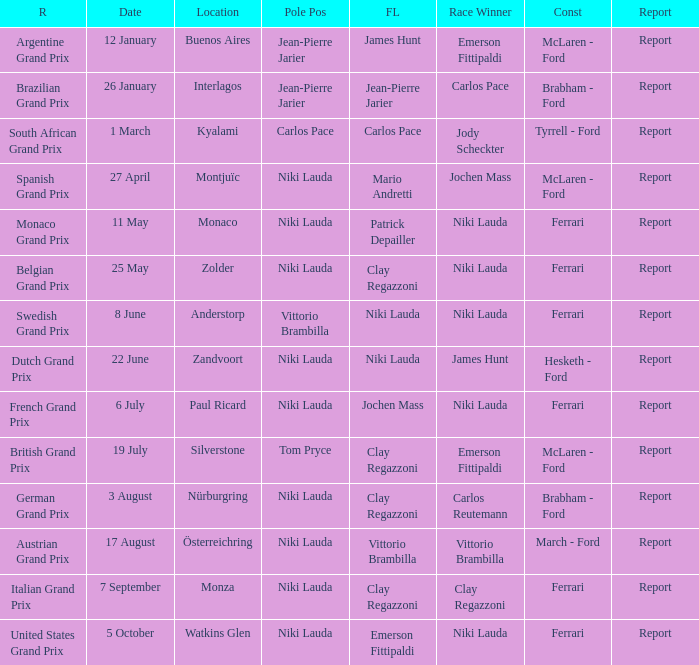Who ran the fastest lap in the team that competed in Zolder, in which Ferrari was the Constructor? Clay Regazzoni. 